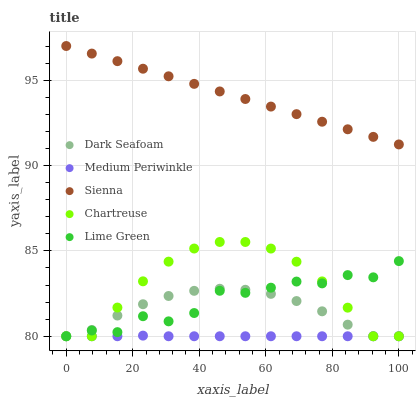Does Medium Periwinkle have the minimum area under the curve?
Answer yes or no. Yes. Does Sienna have the maximum area under the curve?
Answer yes or no. Yes. Does Lime Green have the minimum area under the curve?
Answer yes or no. No. Does Lime Green have the maximum area under the curve?
Answer yes or no. No. Is Sienna the smoothest?
Answer yes or no. Yes. Is Lime Green the roughest?
Answer yes or no. Yes. Is Dark Seafoam the smoothest?
Answer yes or no. No. Is Dark Seafoam the roughest?
Answer yes or no. No. Does Lime Green have the lowest value?
Answer yes or no. Yes. Does Sienna have the highest value?
Answer yes or no. Yes. Does Lime Green have the highest value?
Answer yes or no. No. Is Lime Green less than Sienna?
Answer yes or no. Yes. Is Sienna greater than Lime Green?
Answer yes or no. Yes. Does Medium Periwinkle intersect Chartreuse?
Answer yes or no. Yes. Is Medium Periwinkle less than Chartreuse?
Answer yes or no. No. Is Medium Periwinkle greater than Chartreuse?
Answer yes or no. No. Does Lime Green intersect Sienna?
Answer yes or no. No. 